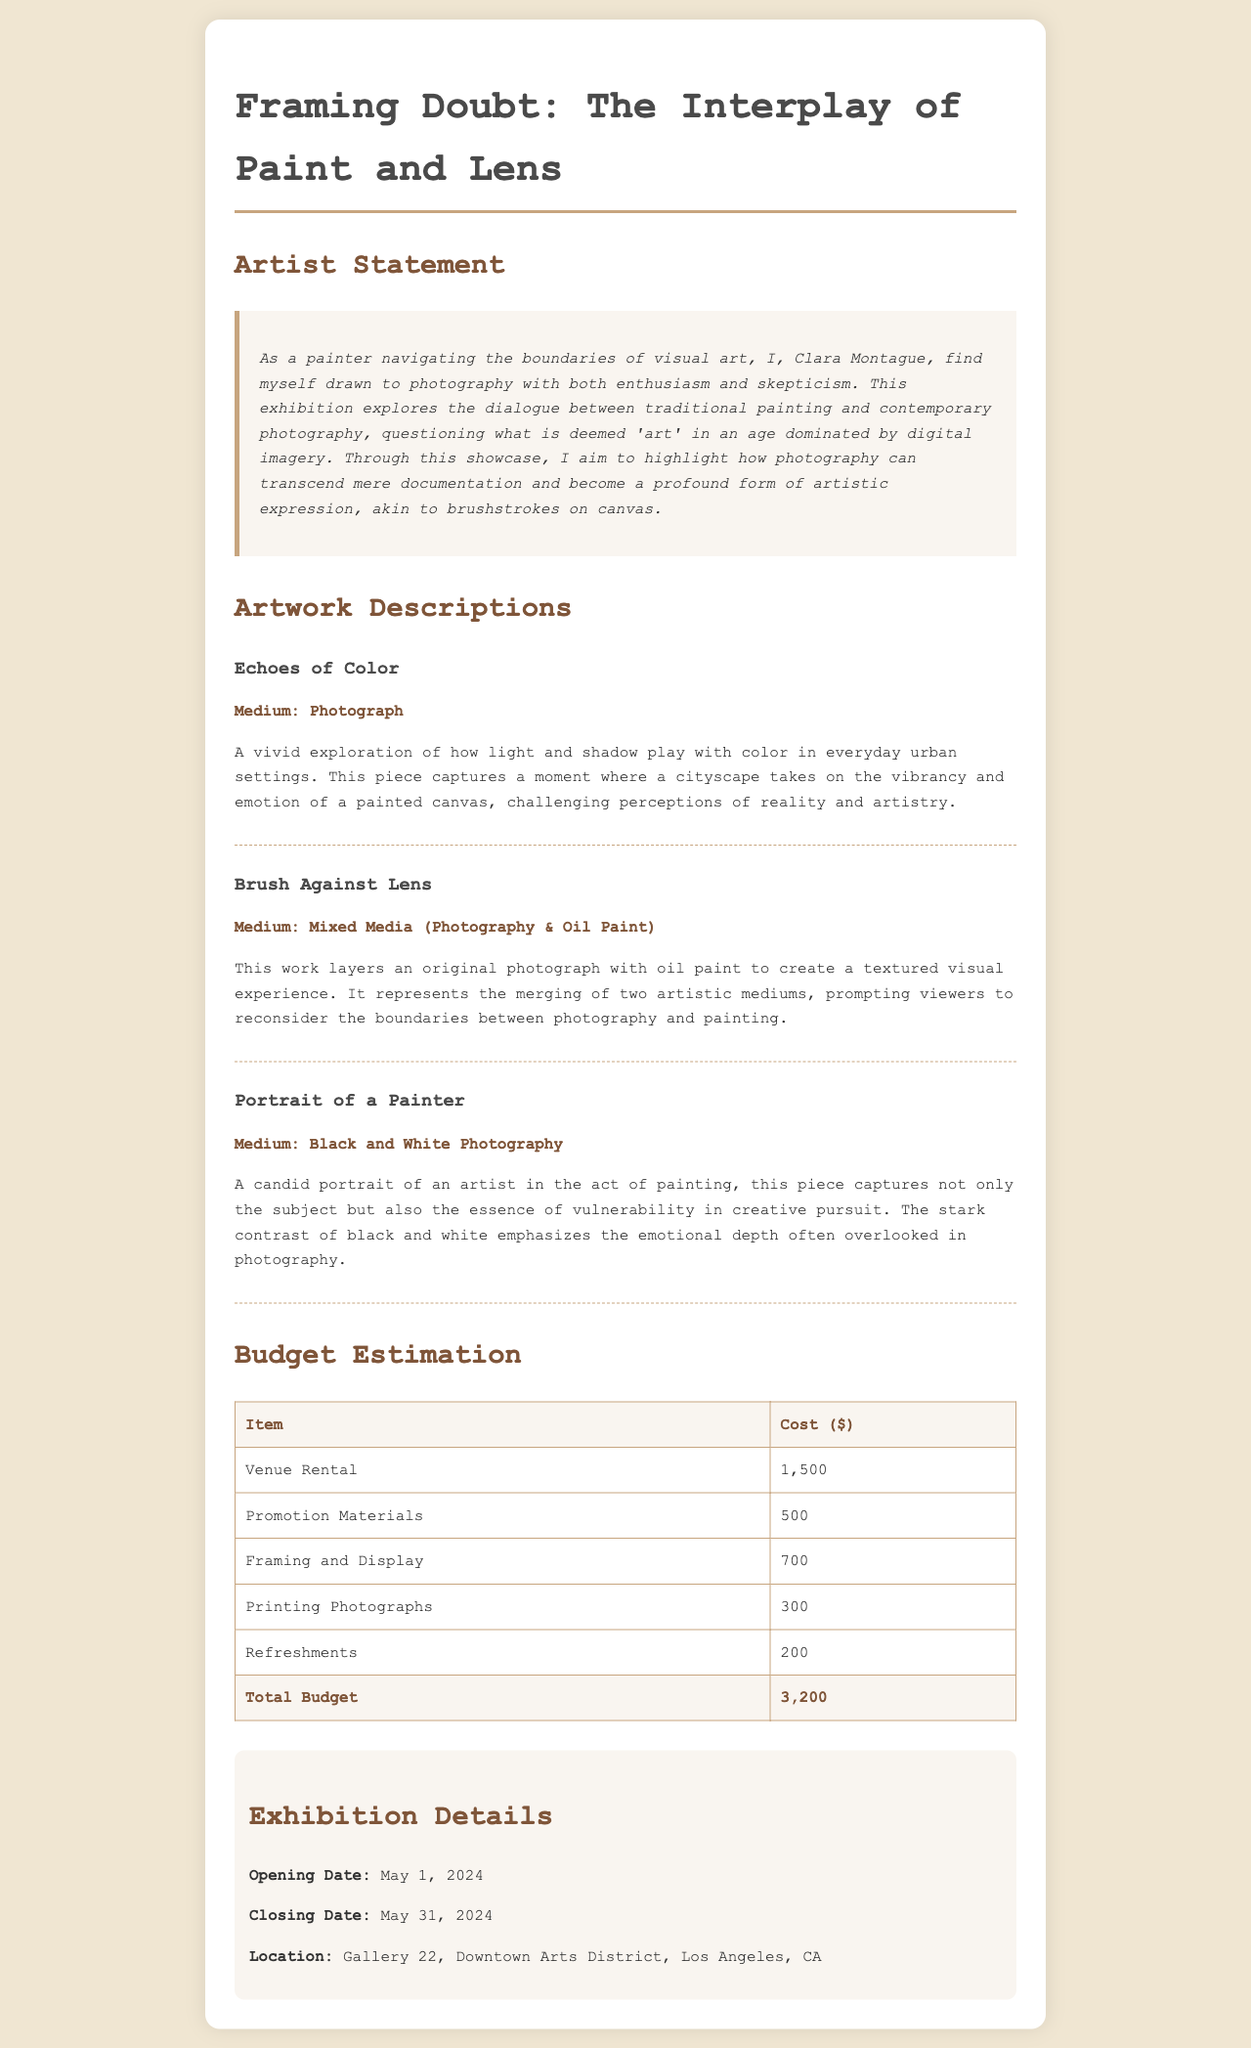What is the title of the exhibition? The title is prominently displayed at the top of the document, indicating the theme of the showcase.
Answer: Framing Doubt: The Interplay of Paint and Lens Who is the artist? The artist's name is mentioned in the artist statement section of the document.
Answer: Clara Montague What is the medium of the artwork "Brush Against Lens"? The medium is listed directly with the artwork description in the document.
Answer: Mixed Media (Photography & Oil Paint) What is the total budget for the exhibition? The total budget is summarized at the end of the budget estimation table.
Answer: 3,200 What are the opening and closing dates of the exhibition? The dates are provided in the exhibition details section of the document, listing the duration of the showcase.
Answer: May 1, 2024 - May 31, 2024 Why does the artist draw skepticism about photography? This is indicated in the artist statement, where the artist expresses their feelings towards the medium.
Answer: Enthusiasm and skepticism How does the artist view the relationship between photography and painting? Insights on this relationship are explored in the artist statement and highlight the artist's perspective.
Answer: A profound form of artistic expression What location will host the exhibition? The location is specified in the exhibition details and indicates where the event will take place.
Answer: Gallery 22, Downtown Arts District, Los Angeles, CA 